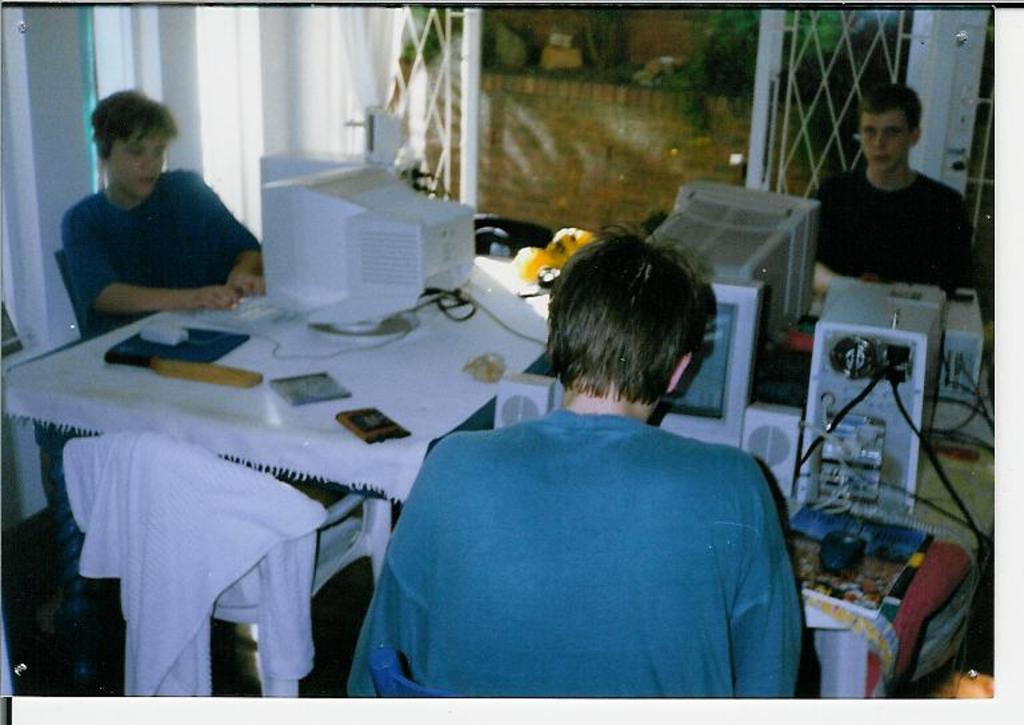Describe this image in one or two sentences. In this image there are three persons. There is a computer, mouse, book, wire on the table. The table is covered with white color cloth, at the back there are plants. 